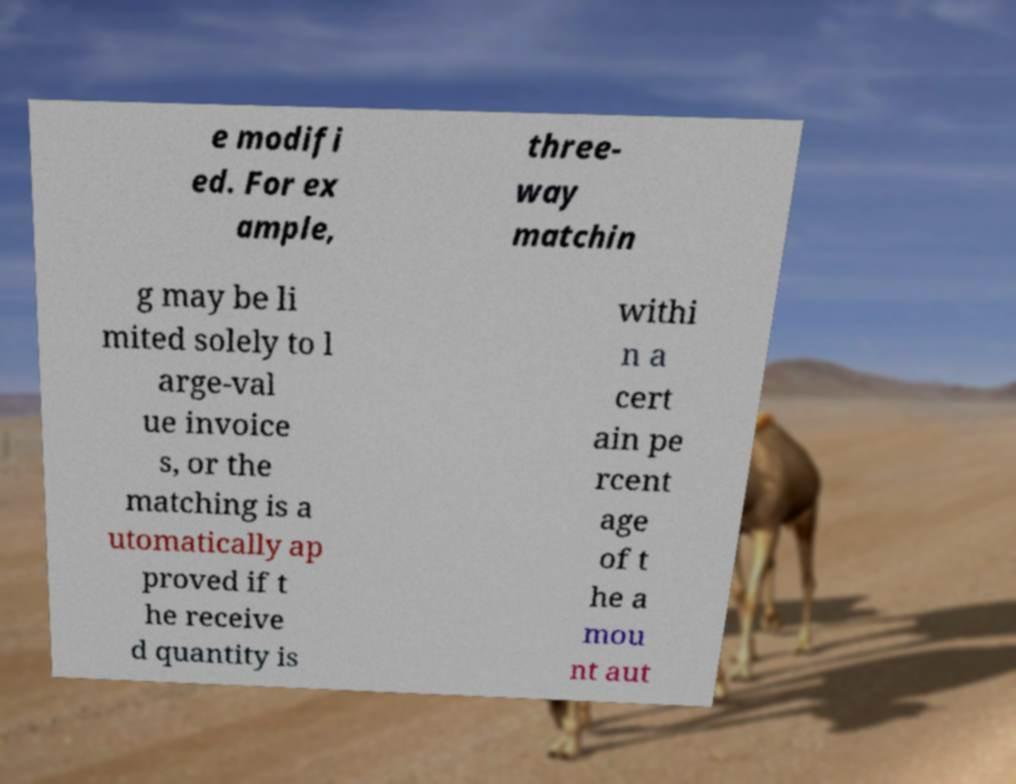What messages or text are displayed in this image? I need them in a readable, typed format. e modifi ed. For ex ample, three- way matchin g may be li mited solely to l arge-val ue invoice s, or the matching is a utomatically ap proved if t he receive d quantity is withi n a cert ain pe rcent age of t he a mou nt aut 